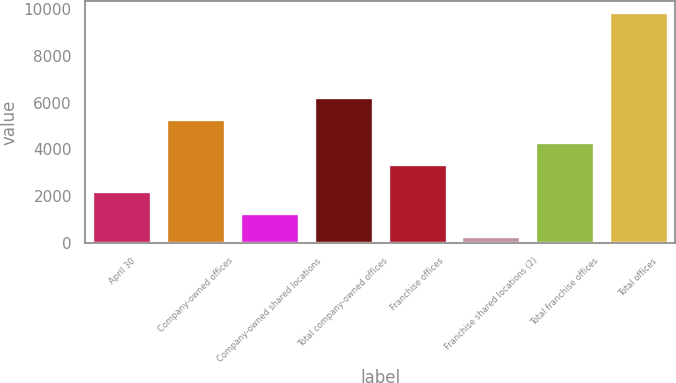Convert chart to OTSL. <chart><loc_0><loc_0><loc_500><loc_500><bar_chart><fcel>April 30<fcel>Company-owned offices<fcel>Company-owned shared locations<fcel>Total company-owned offices<fcel>Franchise offices<fcel>Franchise shared locations (2)<fcel>Total franchise offices<fcel>Total offices<nl><fcel>2230.2<fcel>5279.2<fcel>1277.6<fcel>6231.8<fcel>3374<fcel>325<fcel>4326.6<fcel>9851<nl></chart> 